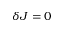Convert formula to latex. <formula><loc_0><loc_0><loc_500><loc_500>\delta J = 0</formula> 